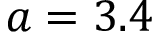<formula> <loc_0><loc_0><loc_500><loc_500>a = 3 . 4</formula> 